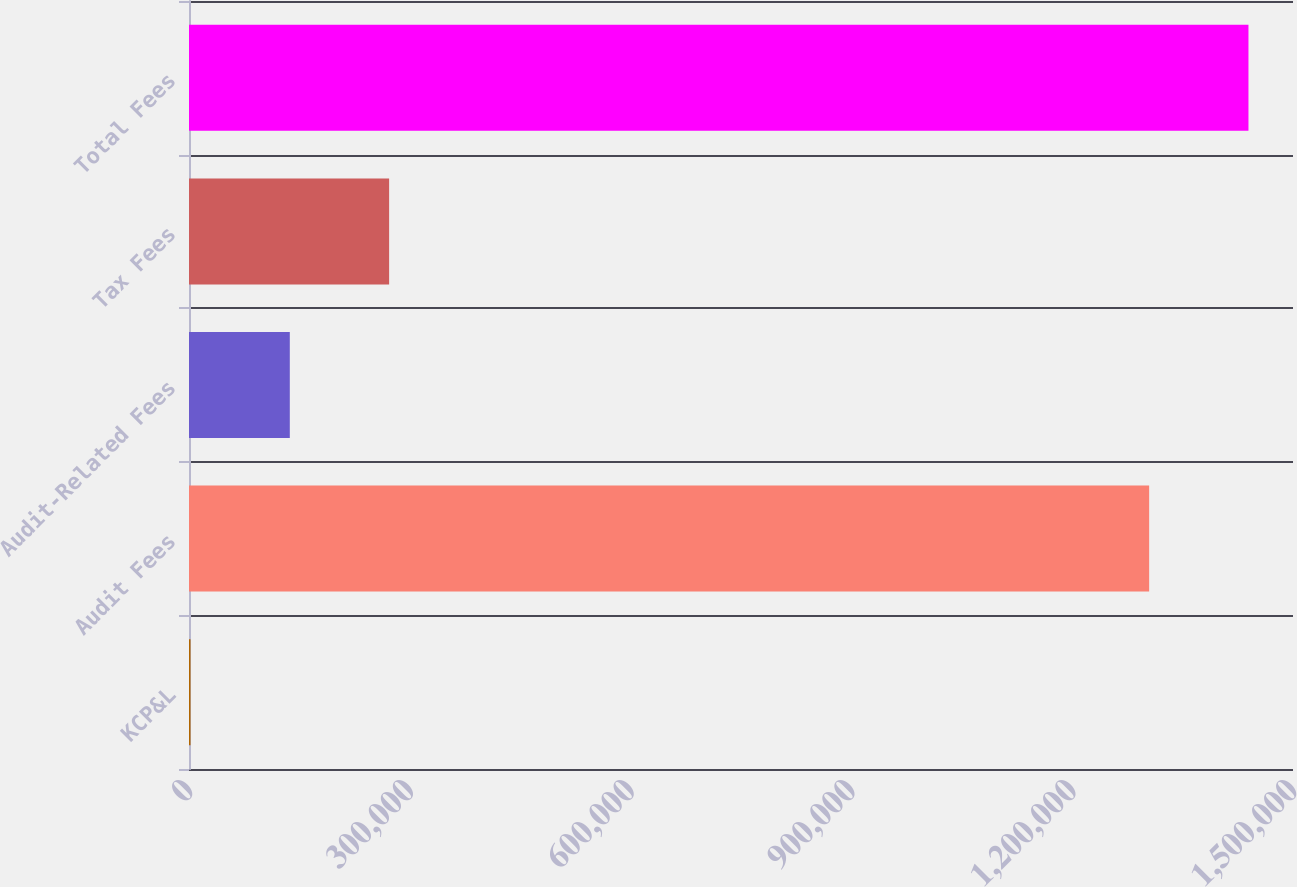Convert chart to OTSL. <chart><loc_0><loc_0><loc_500><loc_500><bar_chart><fcel>KCP&L<fcel>Audit Fees<fcel>Audit-Related Fees<fcel>Tax Fees<fcel>Total Fees<nl><fcel>2017<fcel>1.30455e+06<fcel>136961<fcel>271905<fcel>1.43949e+06<nl></chart> 